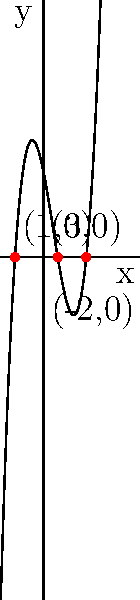Given the polynomial function $f(x) = (x+2)(x-1)(x-3)$, sketch its graph and identify the x-intercepts. How does the graph behave as $x$ approaches positive and negative infinity? Let's approach this step-by-step:

1) First, let's identify the factors of the polynomial:
   $f(x) = (x+2)(x-1)(x-3)$

2) The x-intercepts are the roots of the polynomial, which occur when each factor equals zero:
   $x+2 = 0$, $x = -2$
   $x-1 = 0$, $x = 1$
   $x-3 = 0$, $x = 3$
   So, the x-intercepts are at $x = -2$, $1$, and $3$.

3) The y-intercept can be found by setting $x = 0$:
   $f(0) = (0+2)(0-1)(0-3) = 2(-1)(-3) = 6$
   So, the y-intercept is at $(0,6)$.

4) As this is a cubic function (degree 3), it will have at most two turning points.

5) The end behavior:
   As $x$ approaches positive infinity, $f(x)$ approaches positive infinity.
   As $x$ approaches negative infinity, $f(x)$ approaches negative infinity.
   This is because the leading coefficient is positive (1 in this case).

6) The graph crosses the x-axis at the three x-intercepts, changing from negative to positive at $x = -2$ and $x = 3$, and from positive to negative at $x = 1$.

The sketch shows a cubic function that starts in the third quadrant, crosses into the second quadrant at $x = -2$, reaches a local maximum, crosses into the fourth quadrant at $x = 1$, reaches a local minimum, and finally crosses back into the first quadrant at $x = 3$ before increasing indefinitely.
Answer: The x-intercepts are at $(-2,0)$, $(1,0)$, and $(3,0)$. As $x$ approaches positive infinity, $f(x)$ approaches positive infinity; as $x$ approaches negative infinity, $f(x)$ approaches negative infinity. 